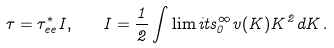<formula> <loc_0><loc_0><loc_500><loc_500>\tau = \tau ^ { * } _ { e e } I , \quad I = \frac { 1 } { 2 } \int \lim i t s _ { 0 } ^ { \infty } v ( K ) K ^ { 2 } d K \, .</formula> 